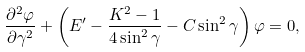<formula> <loc_0><loc_0><loc_500><loc_500>\frac { \partial ^ { 2 } \varphi } { \partial \gamma ^ { 2 } } + \left ( E ^ { \prime } - \frac { K ^ { 2 } - 1 } { 4 \sin ^ { 2 } \gamma } - C \sin ^ { 2 } \gamma \right ) \varphi = 0 ,</formula> 